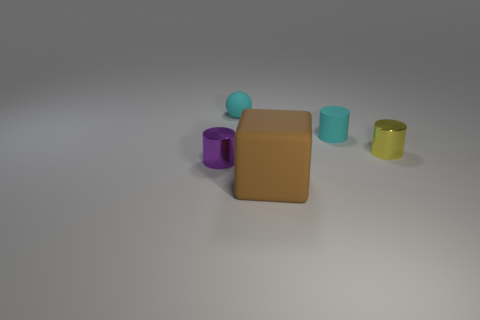Add 1 tiny yellow shiny things. How many objects exist? 6 Subtract all blocks. How many objects are left? 4 Subtract 0 brown spheres. How many objects are left? 5 Subtract all large purple cubes. Subtract all purple cylinders. How many objects are left? 4 Add 5 big matte things. How many big matte things are left? 6 Add 3 tiny matte things. How many tiny matte things exist? 5 